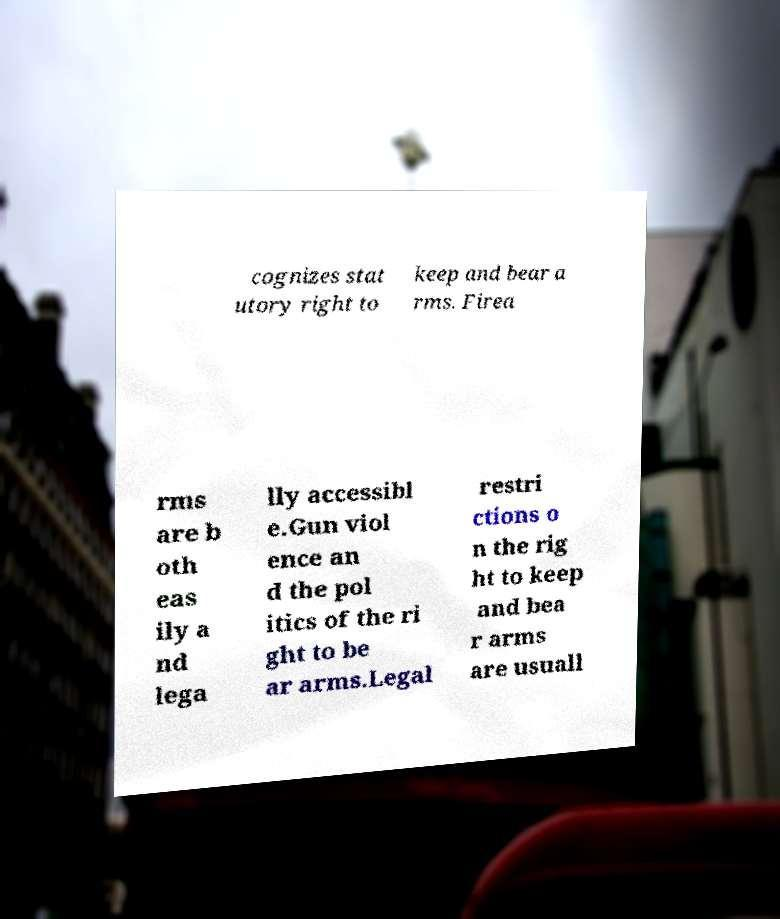Can you read and provide the text displayed in the image?This photo seems to have some interesting text. Can you extract and type it out for me? cognizes stat utory right to keep and bear a rms. Firea rms are b oth eas ily a nd lega lly accessibl e.Gun viol ence an d the pol itics of the ri ght to be ar arms.Legal restri ctions o n the rig ht to keep and bea r arms are usuall 